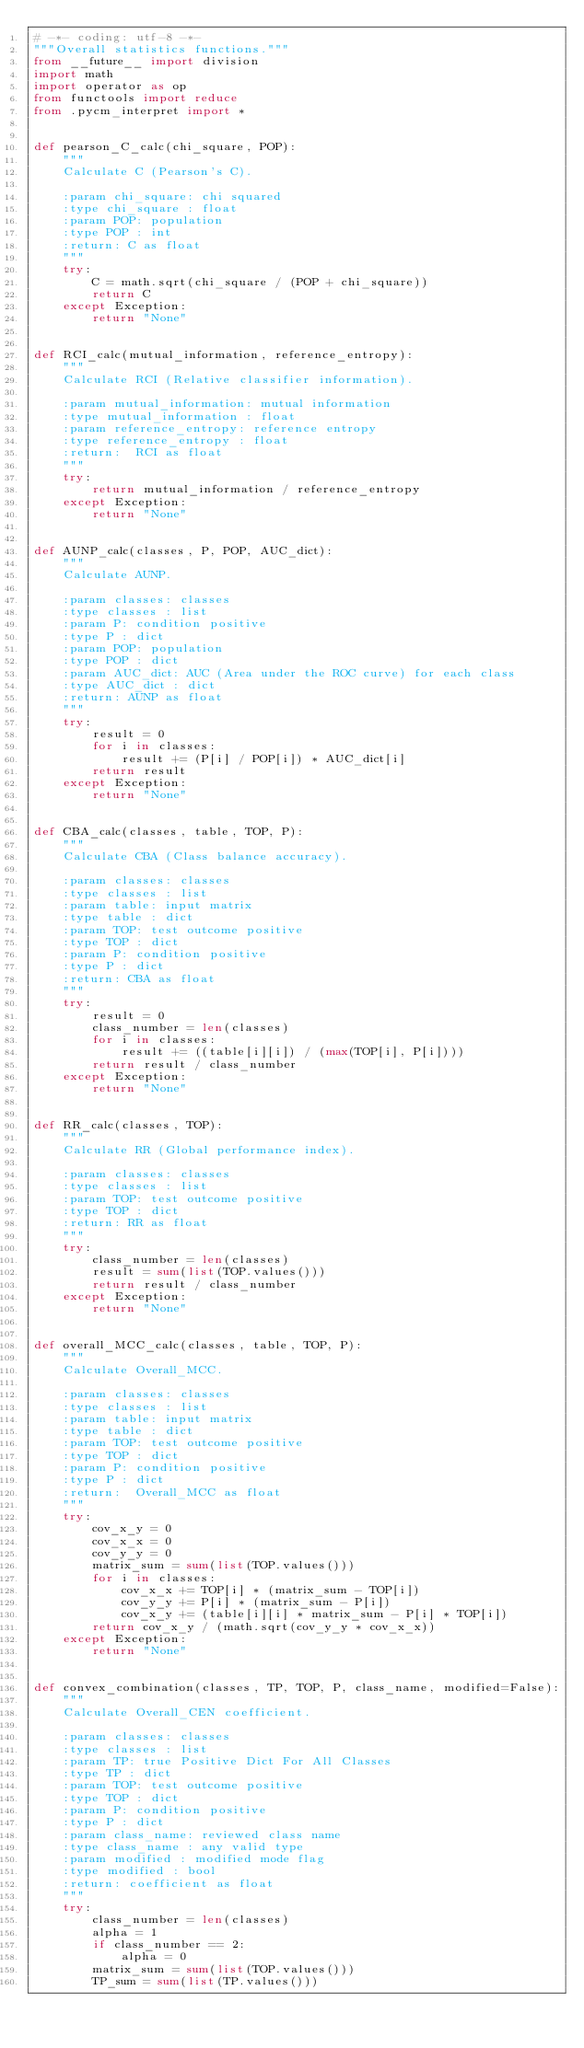Convert code to text. <code><loc_0><loc_0><loc_500><loc_500><_Python_># -*- coding: utf-8 -*-
"""Overall statistics functions."""
from __future__ import division
import math
import operator as op
from functools import reduce
from .pycm_interpret import *


def pearson_C_calc(chi_square, POP):
    """
    Calculate C (Pearson's C).

    :param chi_square: chi squared
    :type chi_square : float
    :param POP: population
    :type POP : int
    :return: C as float
    """
    try:
        C = math.sqrt(chi_square / (POP + chi_square))
        return C
    except Exception:
        return "None"


def RCI_calc(mutual_information, reference_entropy):
    """
    Calculate RCI (Relative classifier information).

    :param mutual_information: mutual information
    :type mutual_information : float
    :param reference_entropy: reference entropy
    :type reference_entropy : float
    :return:  RCI as float
    """
    try:
        return mutual_information / reference_entropy
    except Exception:
        return "None"


def AUNP_calc(classes, P, POP, AUC_dict):
    """
    Calculate AUNP.

    :param classes: classes
    :type classes : list
    :param P: condition positive
    :type P : dict
    :param POP: population
    :type POP : dict
    :param AUC_dict: AUC (Area under the ROC curve) for each class
    :type AUC_dict : dict
    :return: AUNP as float
    """
    try:
        result = 0
        for i in classes:
            result += (P[i] / POP[i]) * AUC_dict[i]
        return result
    except Exception:
        return "None"


def CBA_calc(classes, table, TOP, P):
    """
    Calculate CBA (Class balance accuracy).

    :param classes: classes
    :type classes : list
    :param table: input matrix
    :type table : dict
    :param TOP: test outcome positive
    :type TOP : dict
    :param P: condition positive
    :type P : dict
    :return: CBA as float
    """
    try:
        result = 0
        class_number = len(classes)
        for i in classes:
            result += ((table[i][i]) / (max(TOP[i], P[i])))
        return result / class_number
    except Exception:
        return "None"


def RR_calc(classes, TOP):
    """
    Calculate RR (Global performance index).

    :param classes: classes
    :type classes : list
    :param TOP: test outcome positive
    :type TOP : dict
    :return: RR as float
    """
    try:
        class_number = len(classes)
        result = sum(list(TOP.values()))
        return result / class_number
    except Exception:
        return "None"


def overall_MCC_calc(classes, table, TOP, P):
    """
    Calculate Overall_MCC.

    :param classes: classes
    :type classes : list
    :param table: input matrix
    :type table : dict
    :param TOP: test outcome positive
    :type TOP : dict
    :param P: condition positive
    :type P : dict
    :return:  Overall_MCC as float
    """
    try:
        cov_x_y = 0
        cov_x_x = 0
        cov_y_y = 0
        matrix_sum = sum(list(TOP.values()))
        for i in classes:
            cov_x_x += TOP[i] * (matrix_sum - TOP[i])
            cov_y_y += P[i] * (matrix_sum - P[i])
            cov_x_y += (table[i][i] * matrix_sum - P[i] * TOP[i])
        return cov_x_y / (math.sqrt(cov_y_y * cov_x_x))
    except Exception:
        return "None"


def convex_combination(classes, TP, TOP, P, class_name, modified=False):
    """
    Calculate Overall_CEN coefficient.

    :param classes: classes
    :type classes : list
    :param TP: true Positive Dict For All Classes
    :type TP : dict
    :param TOP: test outcome positive
    :type TOP : dict
    :param P: condition positive
    :type P : dict
    :param class_name: reviewed class name
    :type class_name : any valid type
    :param modified : modified mode flag
    :type modified : bool
    :return: coefficient as float
    """
    try:
        class_number = len(classes)
        alpha = 1
        if class_number == 2:
            alpha = 0
        matrix_sum = sum(list(TOP.values()))
        TP_sum = sum(list(TP.values()))</code> 